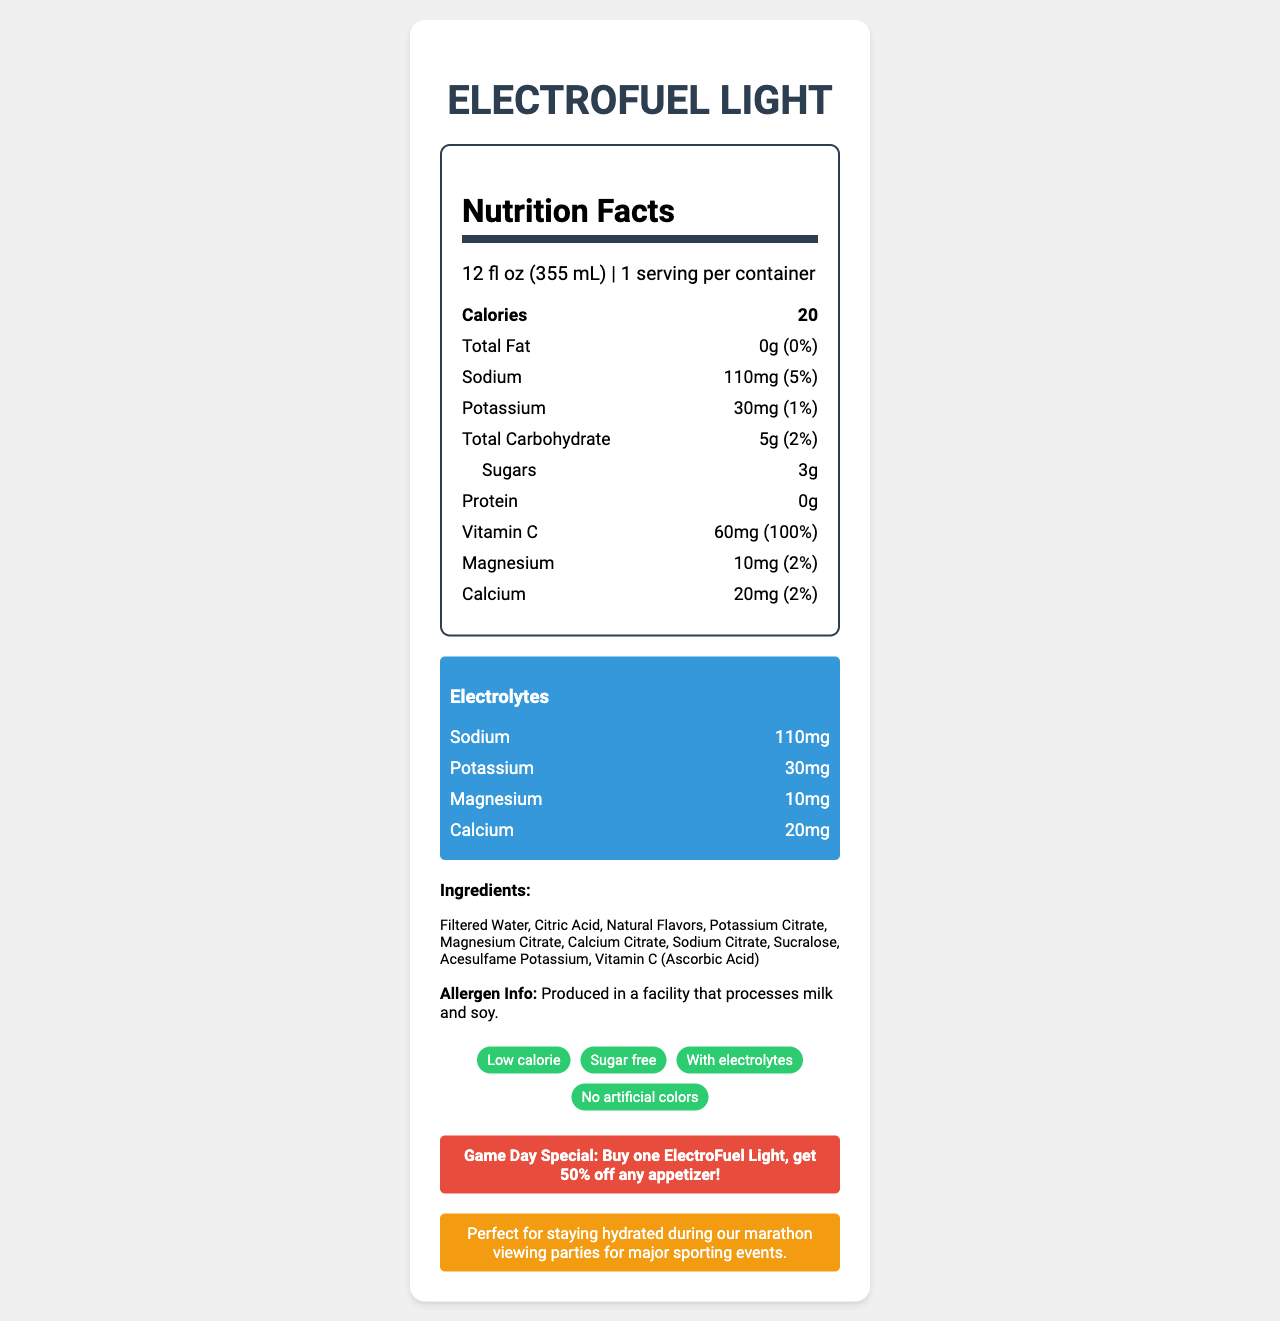what is the product name? The product name is prominently displayed at the top of the document.
Answer: ElectroFuel Light how many calories are in one serving? The document lists the calorie count as 20 under the "Calories" section.
Answer: 20 what is the serving size of this product? The serving size is shown under the "Nutrition Facts" heading and states "12 fl oz (355 mL)".
Answer: 12 fl oz (355 mL) how many grams of total fat does the product contain? The "Total Fat" section lists 0 grams of fat with a daily value of 0%.
Answer: 0g what quantity of sodium is in one serving? The document indicates that one serving contains 110mg of sodium under the "Sodium" section.
Answer: 110mg what are the main ingredients in this product? The ingredients section lists all the components used in making the product.
Answer: Filtered Water, Citric Acid, Natural Flavors, Potassium Citrate, Magnesium Citrate, Calcium Citrate, Sodium Citrate, Sucralose, Acesulfame Potassium, Vitamin C (Ascorbic Acid) how much sugar is in one serving? The "Sugars" section under "Total Carbohydrate" specifies that one serving contains 3 grams of sugars.
Answer: 3g what is the game day special promotion? The promotion details are highlighted in a red box at the bottom of the document.
Answer: Buy one ElectroFuel Light, get 50% off any appetizer! why is ElectroFuel Light a good choice for viewing parties? The document states that the drink is perfect for staying hydrated during marathon viewing parties.
Answer: Perfect for staying hydrated during our marathon viewing parties for major sporting events. which of the following electrolytes are present in ElectroFuel Light? A. Sodium B. Potassium C. Calcium D. Magnesium E. All of the above The document lists all these electrolytes (sodium, potassium, calcium, magnesium) in the "Electrolytes" section.
Answer: E what claim about ElectroFuel Light suggests it is a healthier option? A. High calorie B. Sugar free C. Contains artificial colors D. Low protein The document claims "Sugar free," making it a healthier option.
Answer: B is ElectroFuel Light suitable for someone with a milk allergy? The document states: "Produced in a facility that processes milk and soy," which means there is a risk of cross-contamination.
Answer: No summarize the main idea of the document. This description encompasses the drink's nutritional aspects, its purpose, and the promotional information provided in the document.
Answer: ElectroFuel Light is a low-calorie sports drink designed to keep you hydrated, especially during long viewing parties for major sporting events. It is sugar-free, contains various electrolytes, and comes with a promotional offer at your sports bar. what is the color of the background in the "electrolytes" section? The background color of the "electrolytes" section is specified as #3498db, a shade of blue, according to the document's styling.
Answer: Blue how much potassium does ElectroFuel Light contain? The document lists the potassium content as 30mg in the "Nutrition Facts" and "Electrolytes" sections.
Answer: 30mg what is the percentage of daily value for vitamin C in one serving? The "Vitamin C" section specifies that one serving contains 60mg of Vitamin C, which amounts to 100% of the daily value.
Answer: 100% how many servings are in one container of ElectroFuel Light? The serving information states that there is 1 serving per container.
Answer: 1 what is the container size for ElectroFuel Light? The document specifies the serving size but does not provide information on the total container size.
Answer: Cannot be determined 